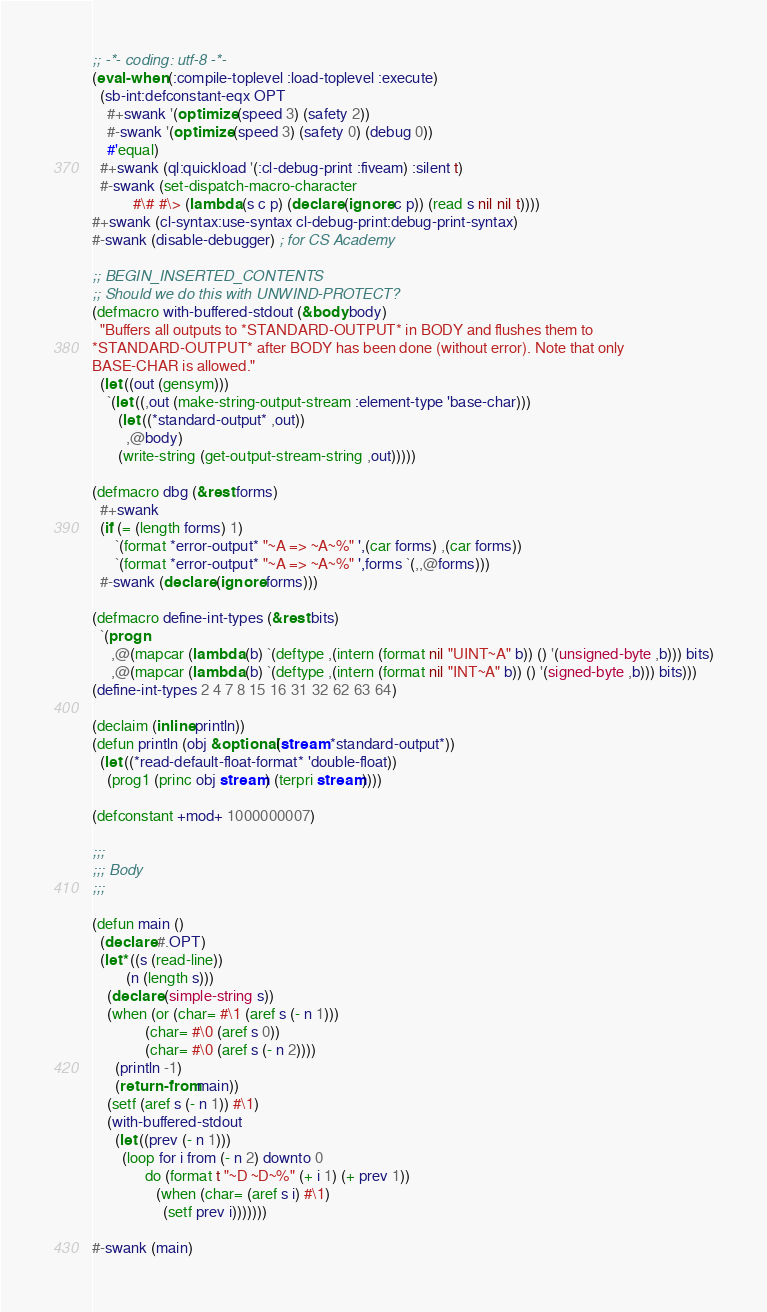Convert code to text. <code><loc_0><loc_0><loc_500><loc_500><_Lisp_>;; -*- coding: utf-8 -*-
(eval-when (:compile-toplevel :load-toplevel :execute)
  (sb-int:defconstant-eqx OPT
    #+swank '(optimize (speed 3) (safety 2))
    #-swank '(optimize (speed 3) (safety 0) (debug 0))
    #'equal)
  #+swank (ql:quickload '(:cl-debug-print :fiveam) :silent t)
  #-swank (set-dispatch-macro-character
           #\# #\> (lambda (s c p) (declare (ignore c p)) (read s nil nil t))))
#+swank (cl-syntax:use-syntax cl-debug-print:debug-print-syntax)
#-swank (disable-debugger) ; for CS Academy

;; BEGIN_INSERTED_CONTENTS
;; Should we do this with UNWIND-PROTECT?
(defmacro with-buffered-stdout (&body body)
  "Buffers all outputs to *STANDARD-OUTPUT* in BODY and flushes them to
*STANDARD-OUTPUT* after BODY has been done (without error). Note that only
BASE-CHAR is allowed."
  (let ((out (gensym)))
    `(let ((,out (make-string-output-stream :element-type 'base-char)))
       (let ((*standard-output* ,out))
         ,@body)
       (write-string (get-output-stream-string ,out)))))

(defmacro dbg (&rest forms)
  #+swank
  (if (= (length forms) 1)
      `(format *error-output* "~A => ~A~%" ',(car forms) ,(car forms))
      `(format *error-output* "~A => ~A~%" ',forms `(,,@forms)))
  #-swank (declare (ignore forms)))

(defmacro define-int-types (&rest bits)
  `(progn
     ,@(mapcar (lambda (b) `(deftype ,(intern (format nil "UINT~A" b)) () '(unsigned-byte ,b))) bits)
     ,@(mapcar (lambda (b) `(deftype ,(intern (format nil "INT~A" b)) () '(signed-byte ,b))) bits)))
(define-int-types 2 4 7 8 15 16 31 32 62 63 64)

(declaim (inline println))
(defun println (obj &optional (stream *standard-output*))
  (let ((*read-default-float-format* 'double-float))
    (prog1 (princ obj stream) (terpri stream))))

(defconstant +mod+ 1000000007)

;;;
;;; Body
;;;

(defun main ()
  (declare #.OPT)
  (let* ((s (read-line))
         (n (length s)))
    (declare (simple-string s))
    (when (or (char= #\1 (aref s (- n 1)))
              (char= #\0 (aref s 0))
              (char= #\0 (aref s (- n 2))))
      (println -1)
      (return-from main))
    (setf (aref s (- n 1)) #\1)
    (with-buffered-stdout
      (let ((prev (- n 1)))
        (loop for i from (- n 2) downto 0
              do (format t "~D ~D~%" (+ i 1) (+ prev 1))
                 (when (char= (aref s i) #\1)
                   (setf prev i)))))))

#-swank (main)
</code> 